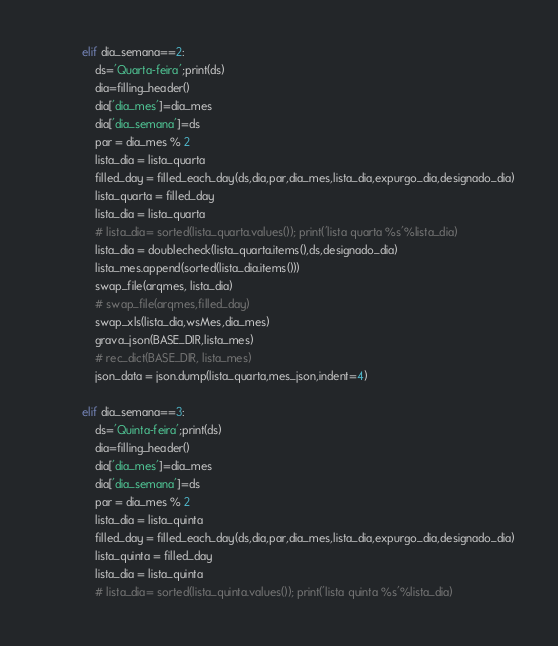Convert code to text. <code><loc_0><loc_0><loc_500><loc_500><_Python_>            elif dia_semana==2:
                ds='Quarta-feira';print(ds)
                dia=filling_header()
                dia['dia_mes']=dia_mes
                dia['dia_semana']=ds
                par = dia_mes % 2
                lista_dia = lista_quarta
                filled_day = filled_each_day(ds,dia,par,dia_mes,lista_dia,expurgo_dia,designado_dia)
                lista_quarta = filled_day
                lista_dia = lista_quarta
                # lista_dia= sorted(lista_quarta.values()); print('lista quarta %s'%lista_dia)
                lista_dia = doublecheck(lista_quarta.items(),ds,designado_dia)
                lista_mes.append(sorted(lista_dia.items()))
                swap_file(arqmes, lista_dia)
                # swap_file(arqmes,filled_day)
                swap_xls(lista_dia,wsMes,dia_mes)
                grava_json(BASE_DIR,lista_mes)
                # rec_dict(BASE_DIR, lista_mes)
                json_data = json.dump(lista_quarta,mes_json,indent=4)

            elif dia_semana==3:
                ds='Quinta-feira';print(ds)
                dia=filling_header()
                dia['dia_mes']=dia_mes
                dia['dia_semana']=ds
                par = dia_mes % 2
                lista_dia = lista_quinta
                filled_day = filled_each_day(ds,dia,par,dia_mes,lista_dia,expurgo_dia,designado_dia)
                lista_quinta = filled_day
                lista_dia = lista_quinta
                # lista_dia= sorted(lista_quinta.values()); print('lista quinta %s'%lista_dia)</code> 